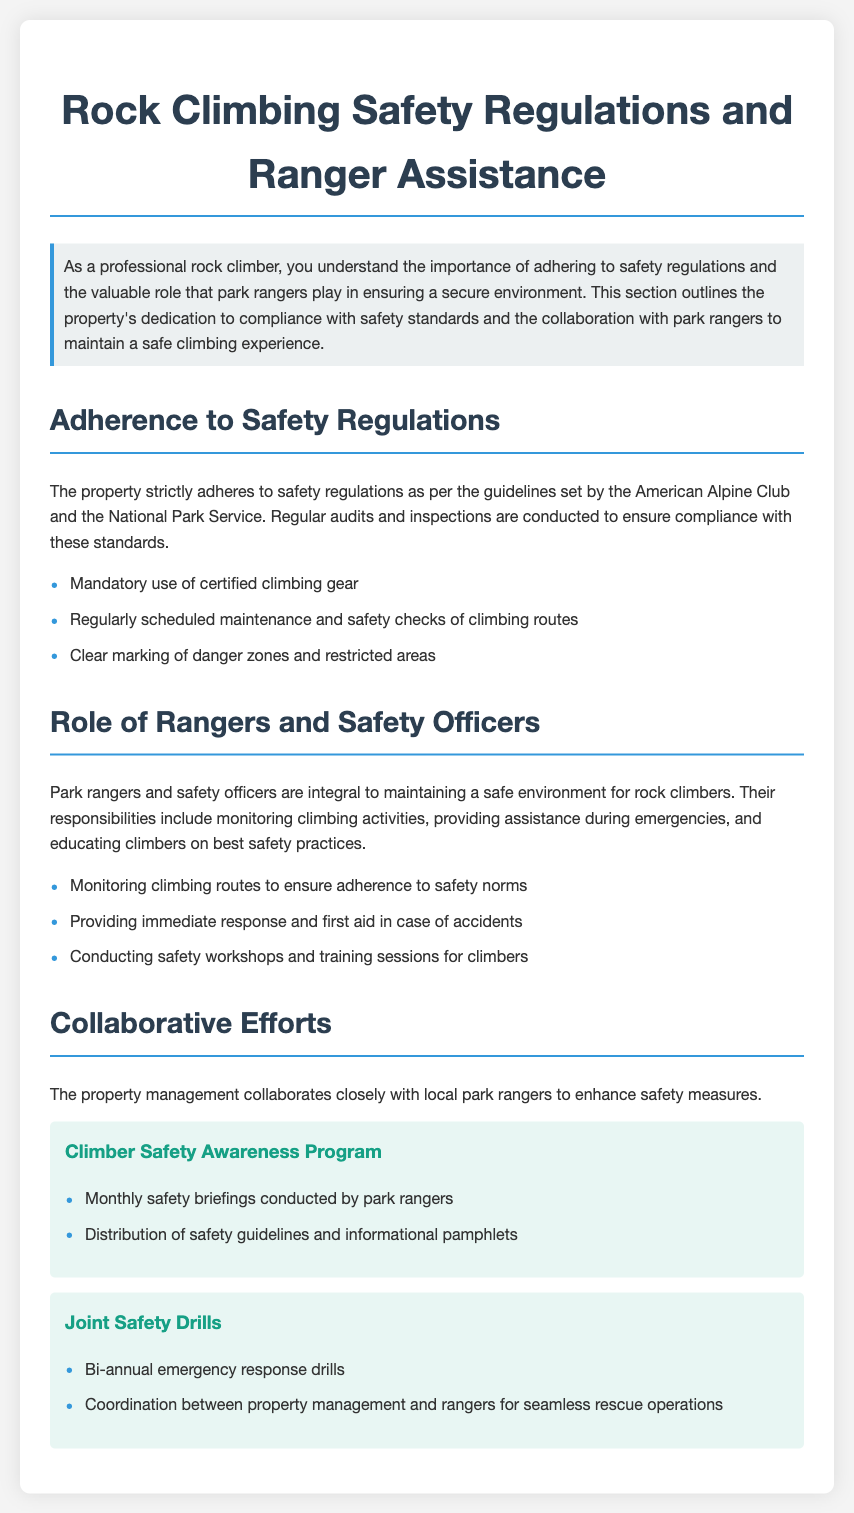What organization’s guidelines does the property adhere to? The guidelines are set by the American Alpine Club and the National Park Service, as mentioned in the document.
Answer: American Alpine Club and the National Park Service What type of gear is mandatory for climbers? The document specifies that climbers must use certified climbing gear, highlighting safety compliance.
Answer: Certified climbing gear How often are safety checks conducted on climbing routes? The document states that safety checks are regularly scheduled but does not specify the frequency.
Answer: Regularly scheduled What is one responsibility of park rangers? The document lists several responsibilities, including monitoring climbing routes to ensure safety.
Answer: Monitoring climbing routes How many types of collaborative safety programs are mentioned? Two specific programs are detailed in the document: Climber Safety Awareness Program and Joint Safety Drills.
Answer: Two What is conducted monthly according to the collaborative efforts? Monthly safety briefings are a part of the Climber Safety Awareness Program, enhancing climber safety.
Answer: Safety briefings What type of drills are held bi-annually? The document mentions bi-annual emergency response drills as part of the Joint Safety Drills program.
Answer: Emergency response drills What is one activity rangers engage in during emergencies? The document states that rangers provide immediate response and first aid in case of accidents.
Answer: First aid What is the role of safety officers according to the document? The document highlights that safety officers help in educating climbers on best safety practices.
Answer: Educating climbers What are the danger zones marked for? The document highlights the marking of danger zones and restricted areas for ensuring climber safety.
Answer: Ensuring climber safety 